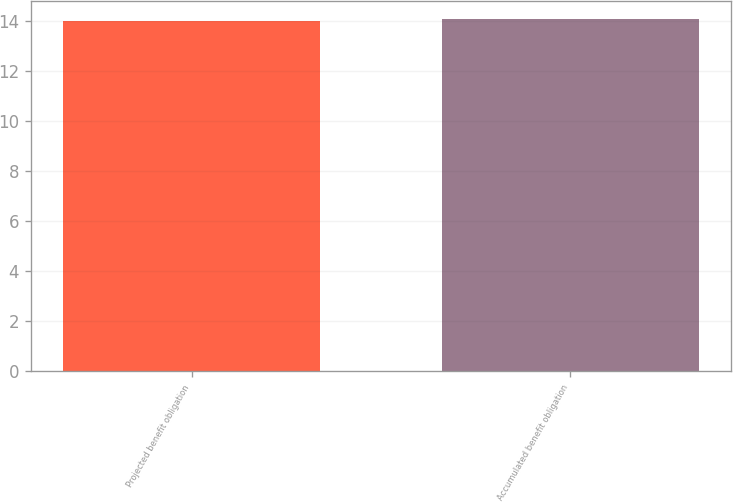Convert chart to OTSL. <chart><loc_0><loc_0><loc_500><loc_500><bar_chart><fcel>Projected benefit obligation<fcel>Accumulated benefit obligation<nl><fcel>14<fcel>14.1<nl></chart> 